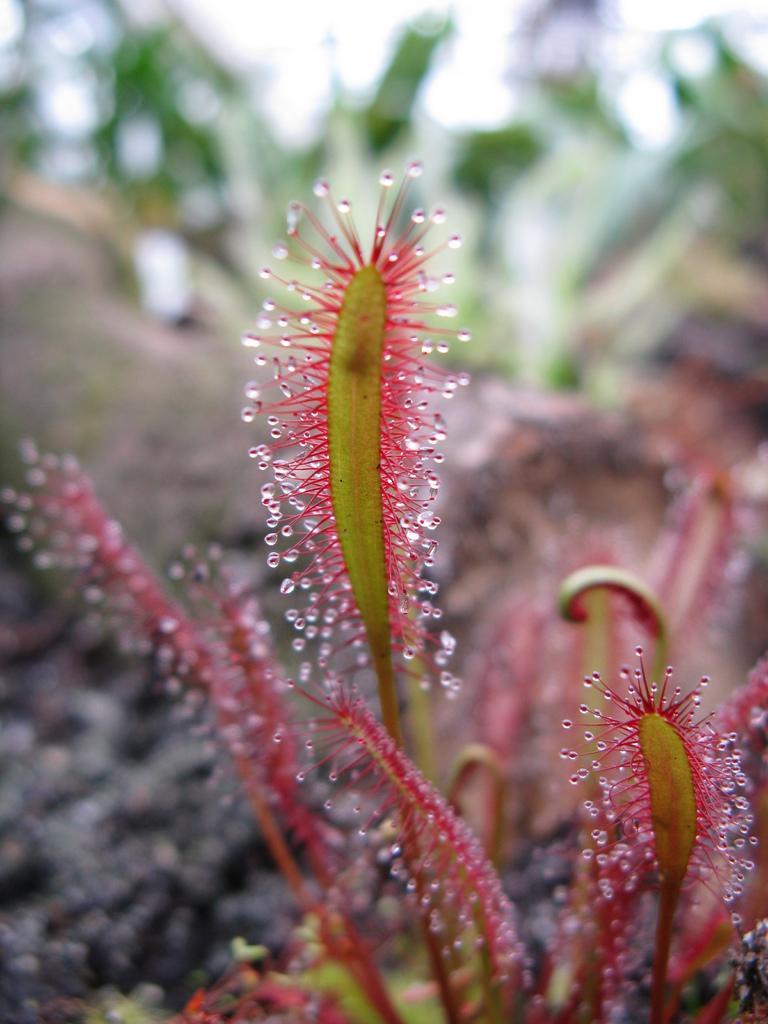Please provide a concise description of this image. In this image it looks like a plants and blur background. 